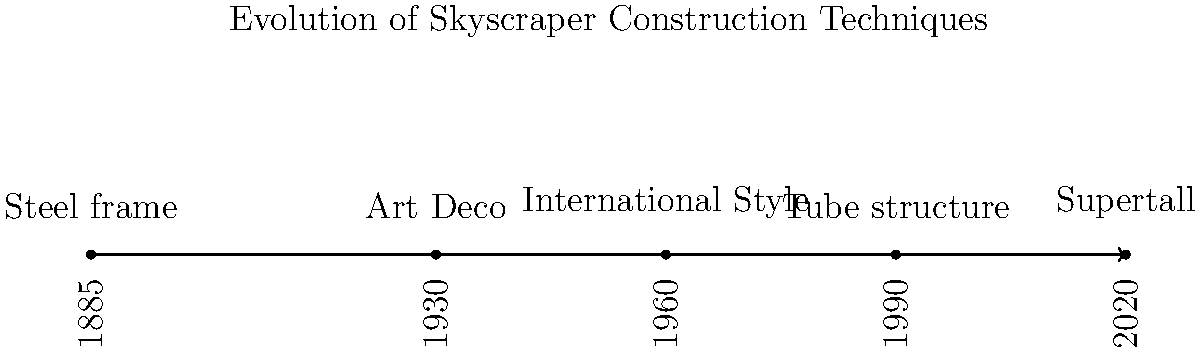Based on the timeline infographic of skyscraper construction techniques, which architectural style dominated the era between the introduction of steel frame construction and the rise of the International Style? To answer this question, let's analyze the timeline step-by-step:

1. The timeline starts in 1885 with the introduction of steel frame construction.
2. The next major development shown is the Art Deco style in 1930.
3. Following Art Deco, we see the International Style emerging in 1960.
4. The period between steel frame construction (1885) and the International Style (1960) is dominated by the Art Deco style (1930).
5. Art Deco was particularly prominent in skyscraper design during the 1920s and 1930s, bridging the gap between the early use of steel frames and the later adoption of the International Style.
6. Notable examples of Art Deco skyscrapers include the Chrysler Building and the Empire State Building in New York City, both completed in the early 1930s.
7. The Art Deco style was characterized by its use of geometric shapes, bold colors, and lavish ornamentation, which contrasted with both the earlier Beaux-Arts style and the later, more austere International Style.

Therefore, the architectural style that dominated the era between the introduction of steel frame construction and the rise of the International Style was Art Deco.
Answer: Art Deco 